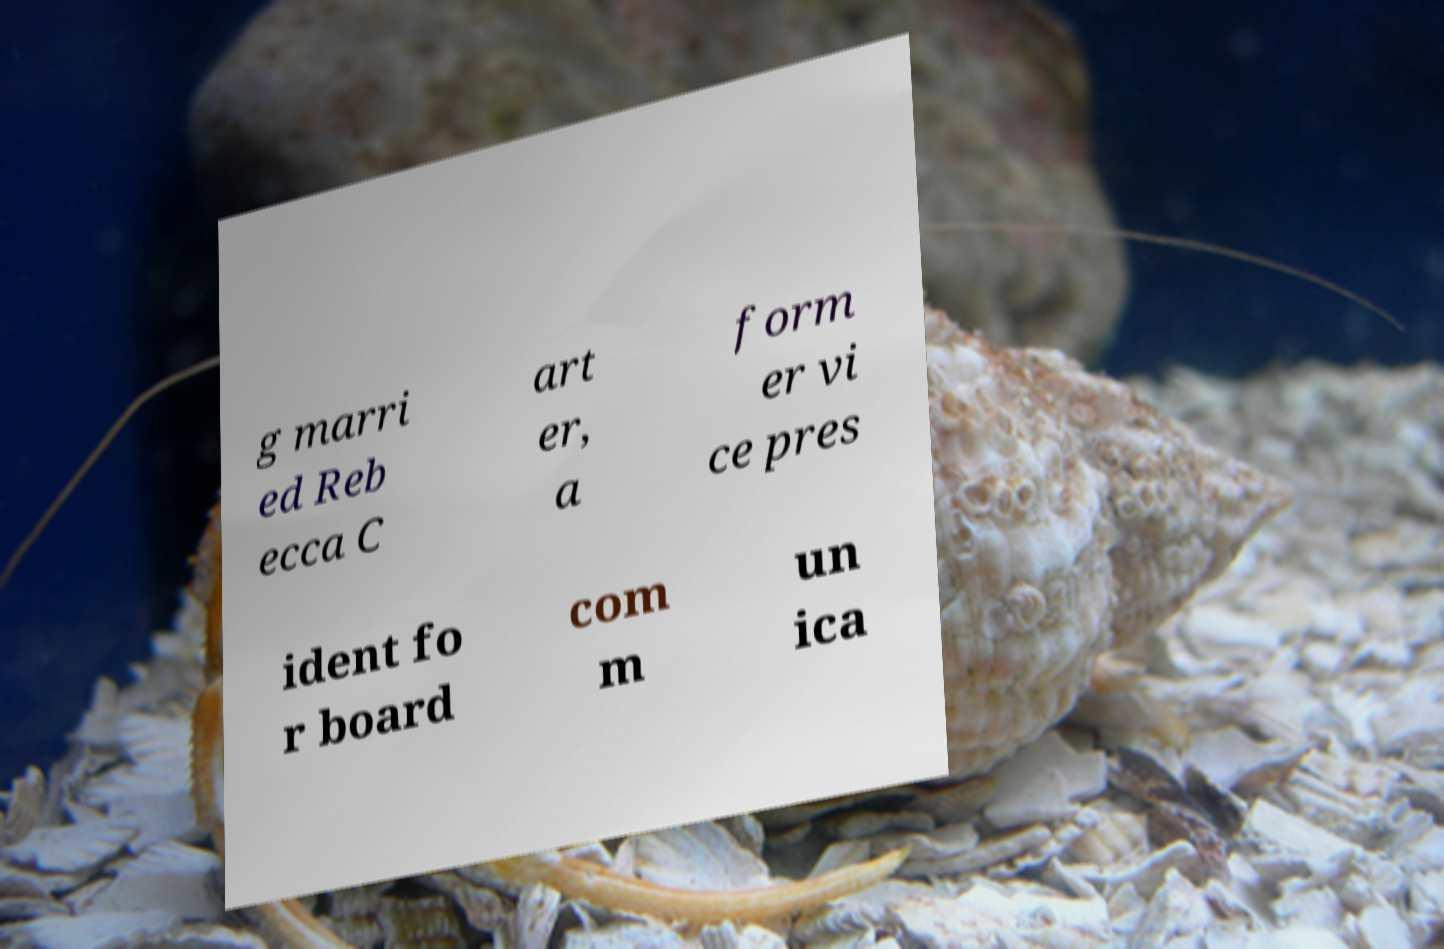Can you accurately transcribe the text from the provided image for me? g marri ed Reb ecca C art er, a form er vi ce pres ident fo r board com m un ica 